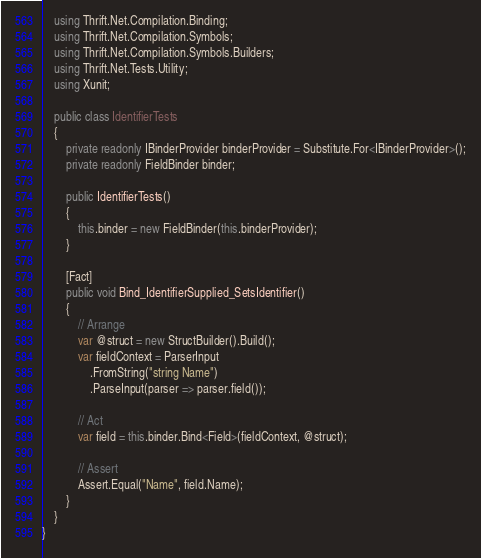Convert code to text. <code><loc_0><loc_0><loc_500><loc_500><_C#_>    using Thrift.Net.Compilation.Binding;
    using Thrift.Net.Compilation.Symbols;
    using Thrift.Net.Compilation.Symbols.Builders;
    using Thrift.Net.Tests.Utility;
    using Xunit;

    public class IdentifierTests
    {
        private readonly IBinderProvider binderProvider = Substitute.For<IBinderProvider>();
        private readonly FieldBinder binder;

        public IdentifierTests()
        {
            this.binder = new FieldBinder(this.binderProvider);
        }

        [Fact]
        public void Bind_IdentifierSupplied_SetsIdentifier()
        {
            // Arrange
            var @struct = new StructBuilder().Build();
            var fieldContext = ParserInput
                .FromString("string Name")
                .ParseInput(parser => parser.field());

            // Act
            var field = this.binder.Bind<Field>(fieldContext, @struct);

            // Assert
            Assert.Equal("Name", field.Name);
        }
    }
}</code> 